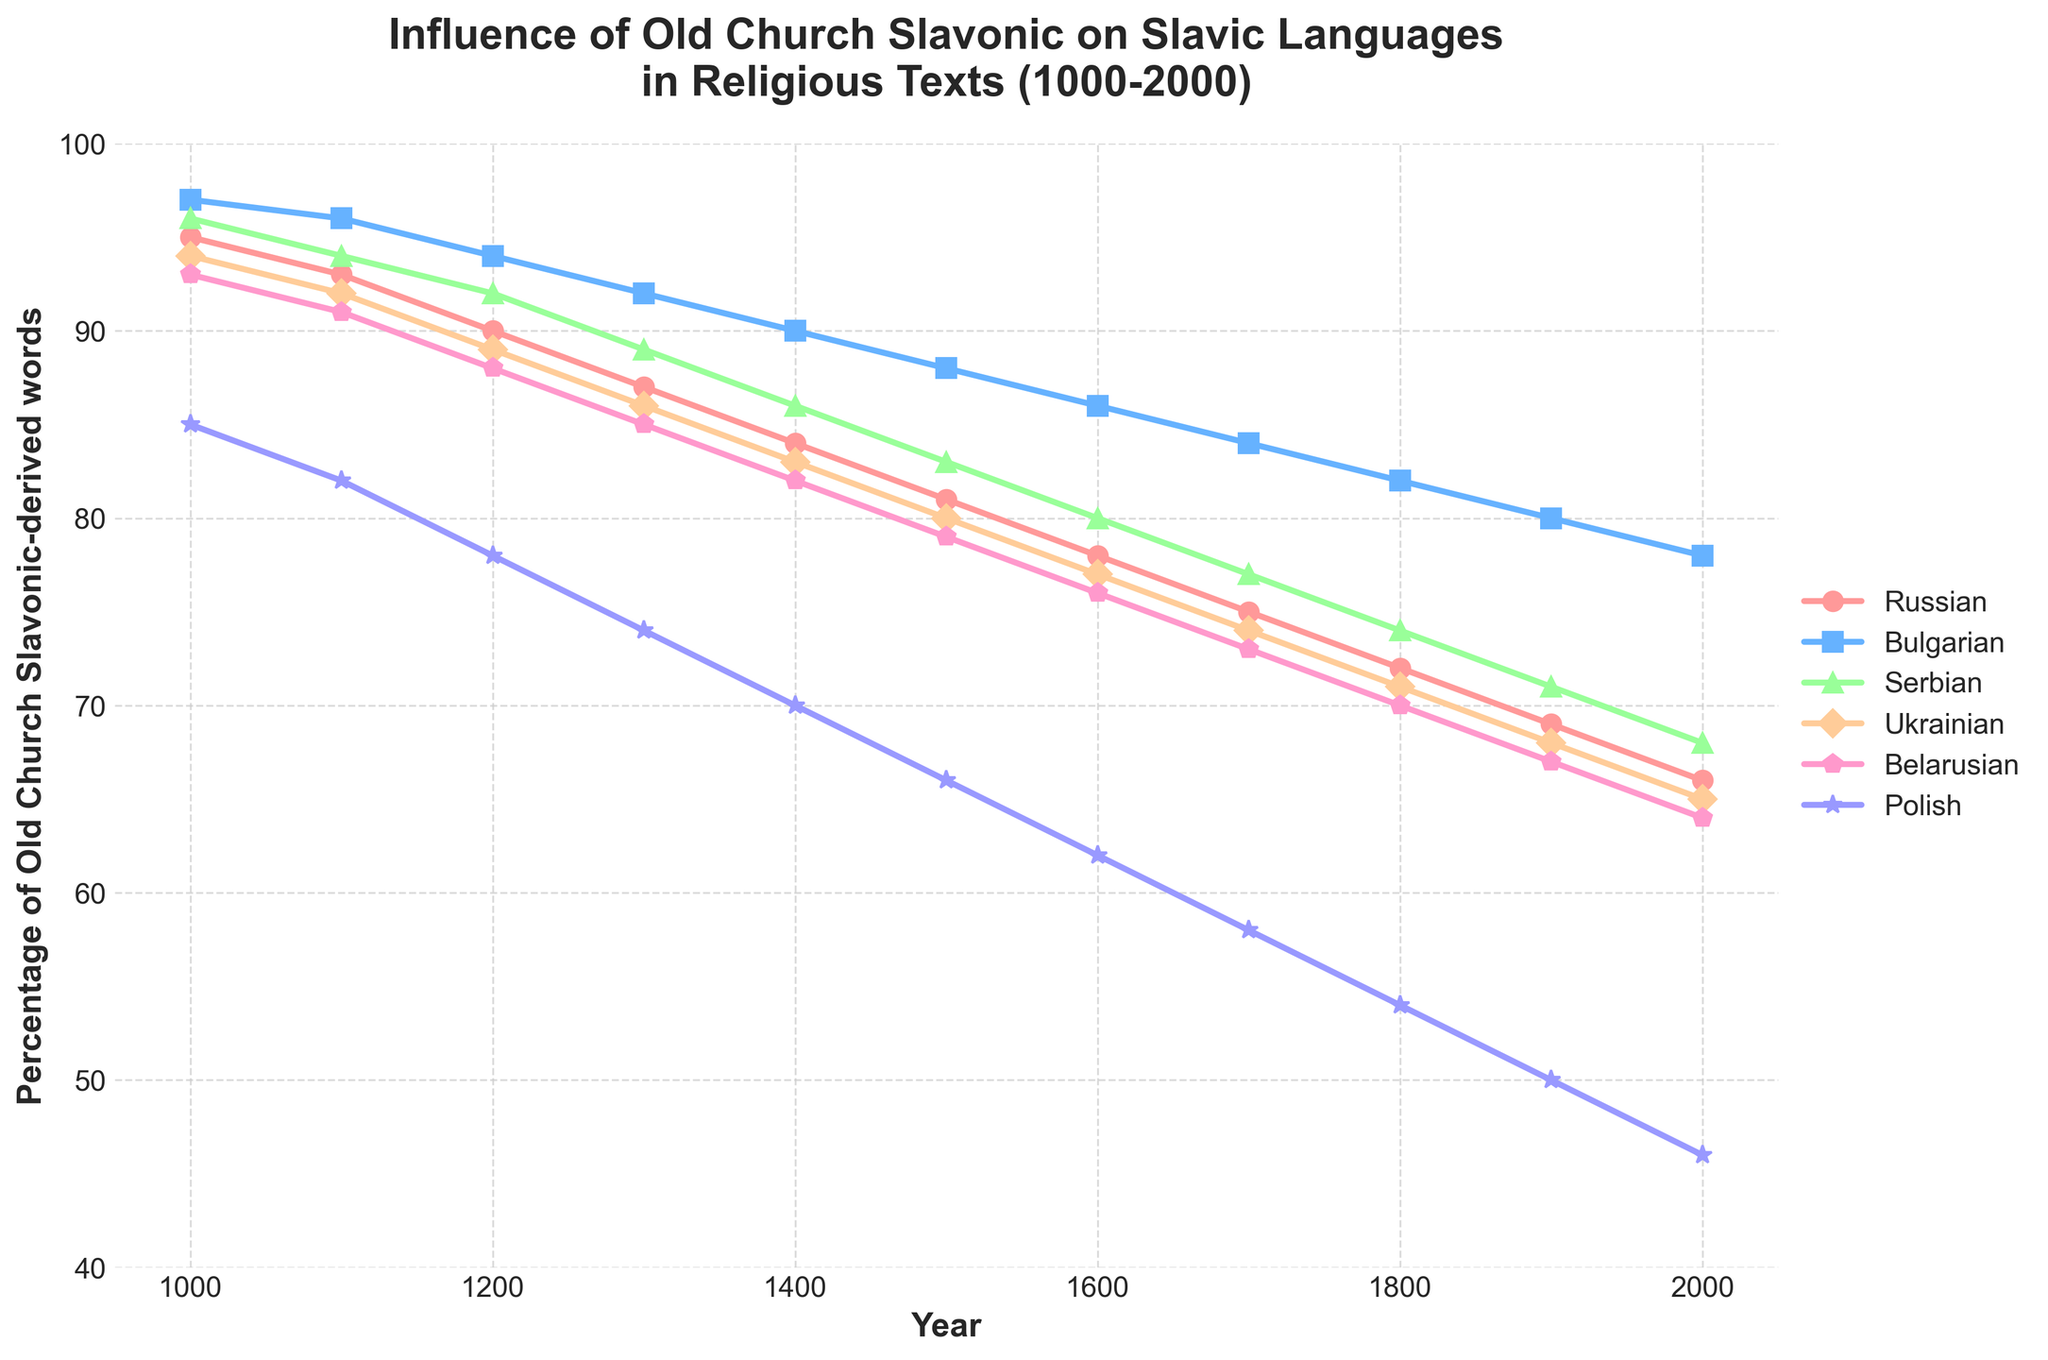What is the trend in the percentage of Old Church Slavonic-derived words in Polish religious texts from 1000 to 2000? The percentage of Old Church Slavonic-derived words in Polish religious texts has a decreasing trend from 85% in the year 1000 to 46% in the year 2000. The percentage consistently decreases over time, showing a steady decline.
Answer: Decreasing Which Slavic language had the highest percentage of Old Church Slavonic-derived words in the year 1500 and by how much? In the year 1500, Bulgarian had the highest percentage of Old Church Slavonic-derived words at 88%. This is determined by observing the values for each language in 1500 and identifying the maximum value.
Answer: Bulgarian, 88% What is the overall decline in the percentage of Old Church Slavonic-derived words in Ukrainian religious texts from the year 1000 to 2000? The percentage of Old Church Slavonic-derived words in Ukrainian religious texts declined from 94% in 1000 to 65% in 2000. Subtract the final percentage in 2000 (65%) from the initial percentage in 1000 (94%) to find the decline: 94% - 65% = 29%.
Answer: 29% In which century did Belarusian religious texts experience the steepest decline in the percentage of Old Church Slavonic-derived words, and what was the percentage change? To identify the steepest decline, observe the differences per century for Belarusian. The steepest decline occurred between the 1000s and 1100s where Belarusian went from 93% to 91%, a change of 2%. However, larger declines are observed later on: between 1400 and 1500 (82% to 79%) and between 1800 and 1900 (70% to 67%), but the largest was between 1500 and 1600 (79% to 76%), a change of 3%.
Answer: 1500-1600, 3% How does the percentage of Old Church Slavonic-derived words in Serbian religious texts in 1200 compare to that in 1800? In 1200, the percentage is 92%, and in 1800 it is 74%. Comparing these values, Serbian religious texts in 1800 had a lower percentage of Old Church Slavonic-derived words than in 1200.
Answer: Lower in 1800 Which language shows the least amount of change in the percentage of Old Church Slavonic-derived words between 1500 and 1900, and what is the percentage change? Calculate the change for each language:
- Russian: 69% - 81% = -12%
- Bulgarian: 80% - 88% = -8%
- Serbian: 71% - 83% = -12%
- Ukrainian: 68% - 80% = -12%
- Belarusian: 67% - 79% = -12%
- Polish: 50% - 66% = -16%
Bulgarian shows the least change with a percentage change of -8%.
Answer: Bulgarian, -8% 